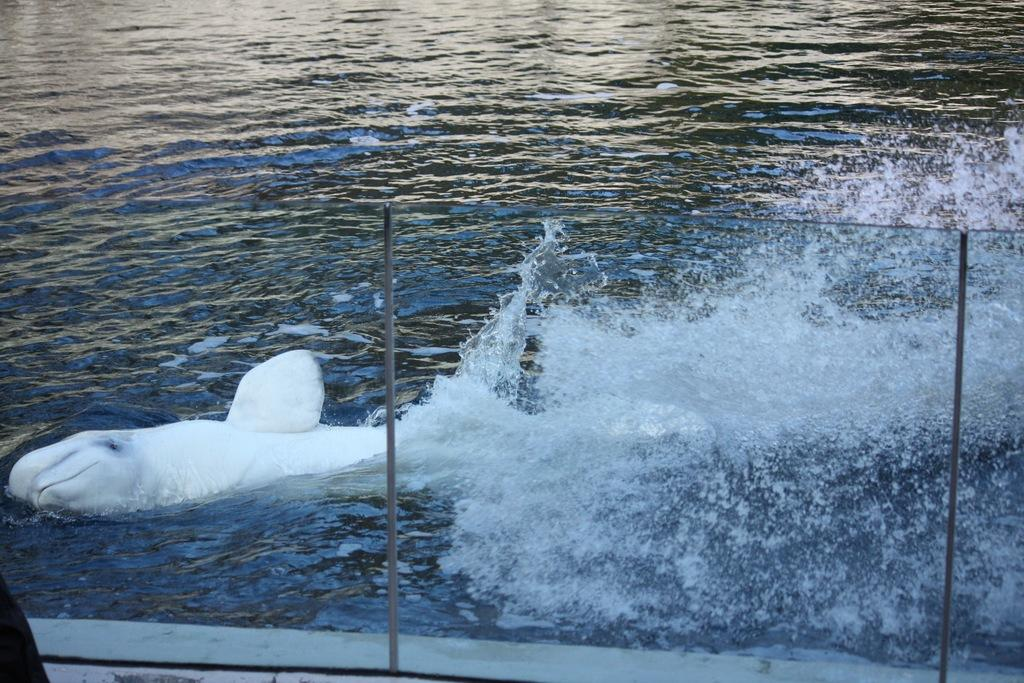What type of fence is visible in the image? There is a glass fence with metal rods in the image. What can be seen on the other side of the fence? On the other side of the fence, there is a shark in the water. What type of cheese is being offered to the passenger in the image? There is no cheese or passenger present in the image; it features a glass fence with metal rods and a shark in the water. 